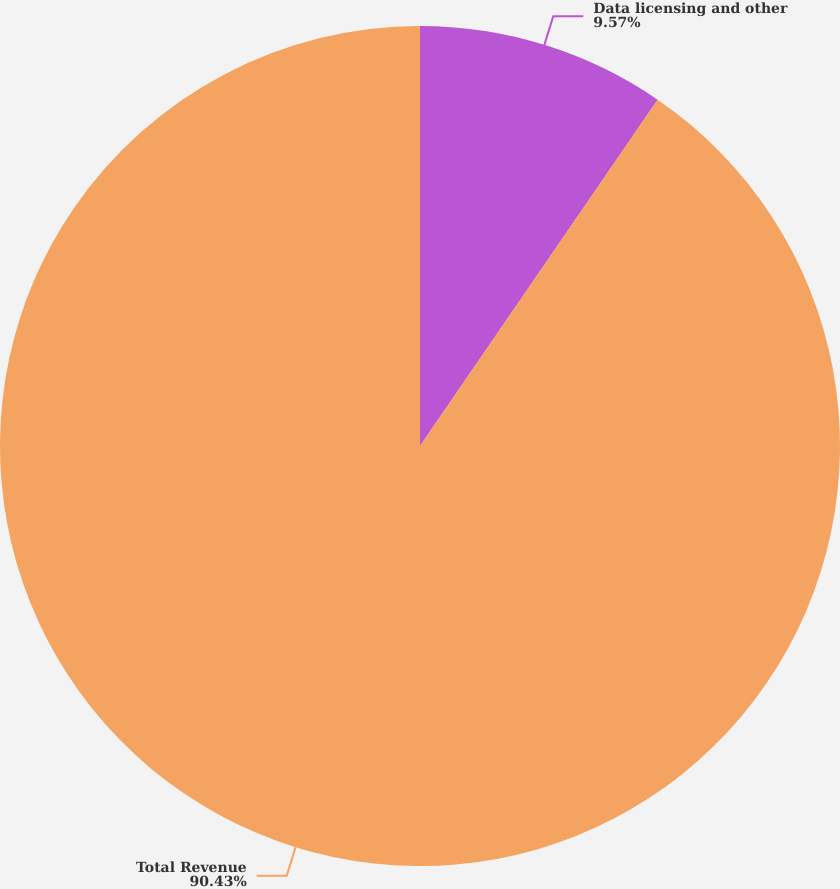Convert chart to OTSL. <chart><loc_0><loc_0><loc_500><loc_500><pie_chart><fcel>Data licensing and other<fcel>Total Revenue<nl><fcel>9.57%<fcel>90.43%<nl></chart> 